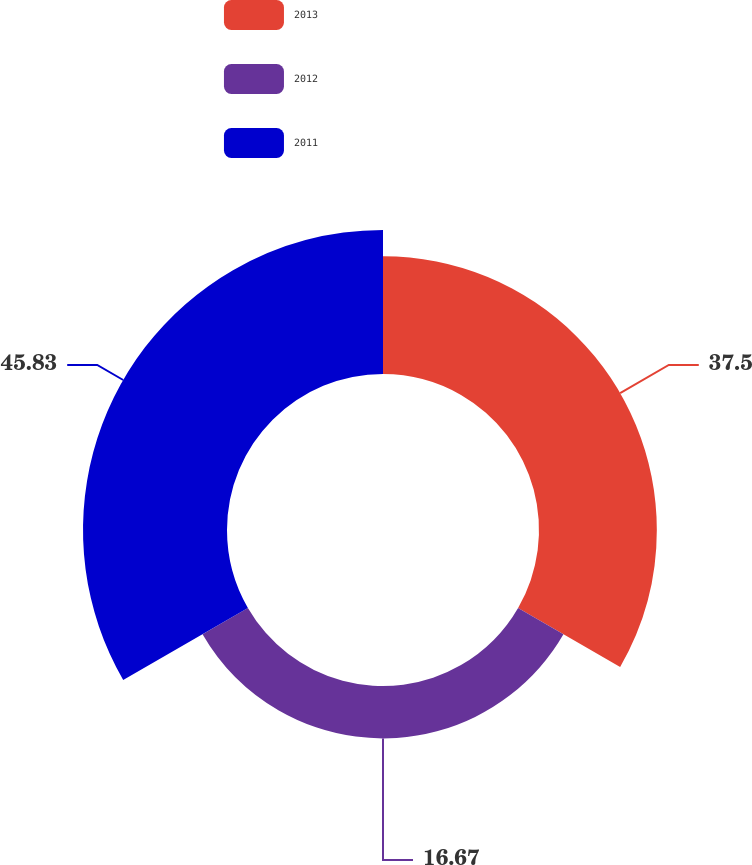<chart> <loc_0><loc_0><loc_500><loc_500><pie_chart><fcel>2013<fcel>2012<fcel>2011<nl><fcel>37.5%<fcel>16.67%<fcel>45.83%<nl></chart> 